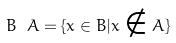<formula> <loc_0><loc_0><loc_500><loc_500>B \ A = \{ x \in B | x \notin A \}</formula> 